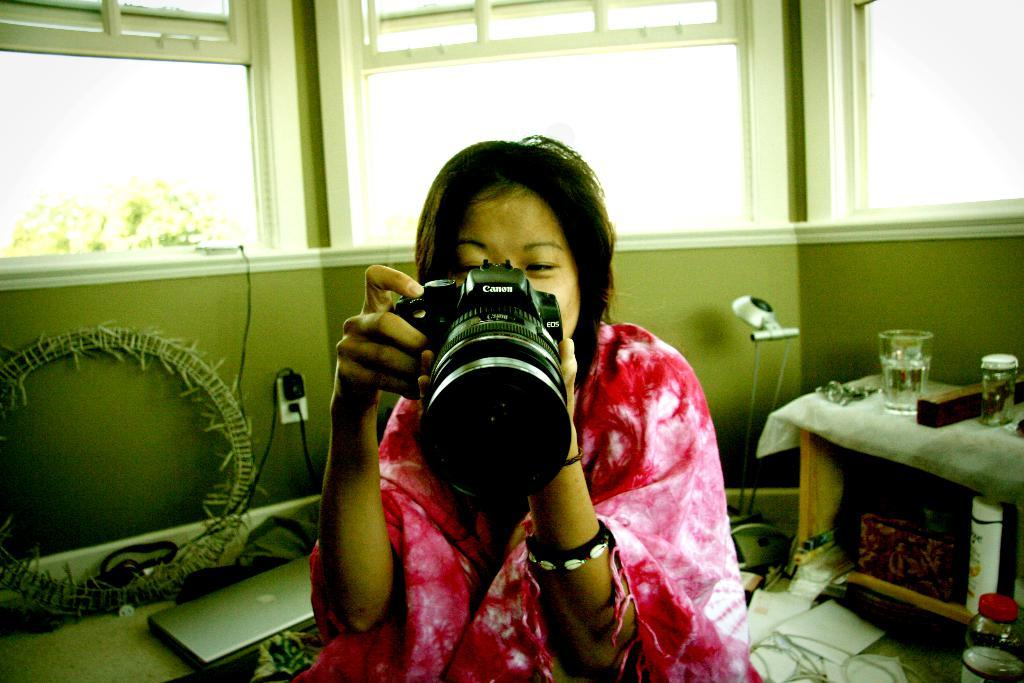Who is the main subject in the image? There is a woman in the image. What is the woman holding in the image? The woman is holding a camera. What electronic device is visible in the image? There is a laptop in the image. What can be seen on the table in the image? There is a glass on a table in the image. What type of step is visible in the image? There is no step present in the image. How many flights can be seen in the image? There are no flights visible in the image. 